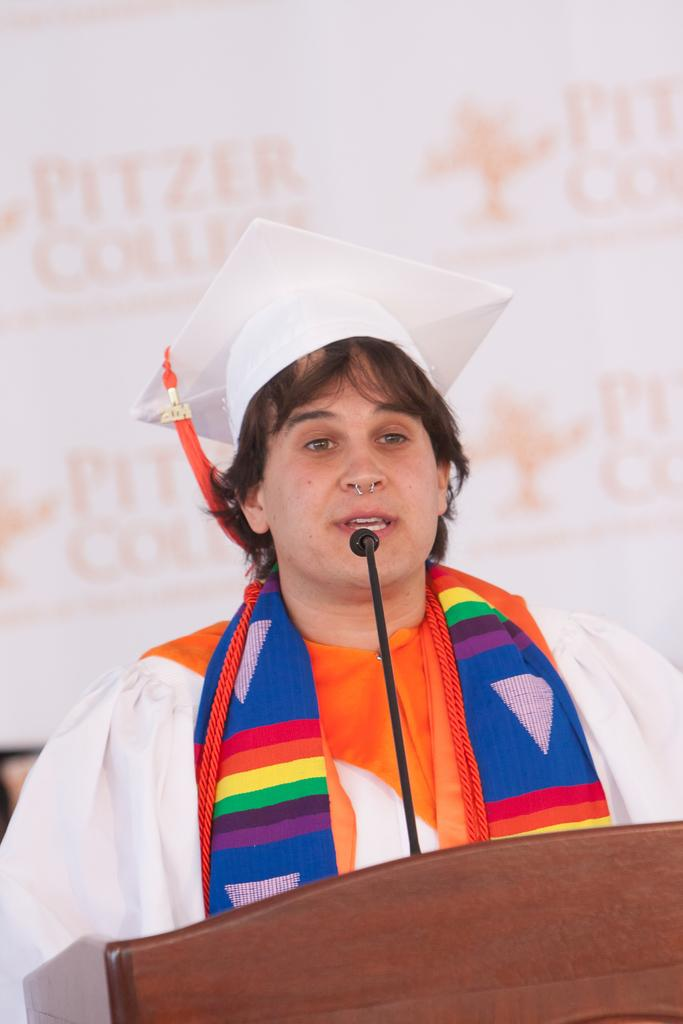What is the person in the image doing? The person appears to be standing near a podium and speaking into a microphone. Where is the microphone located in the image? The microphone is in front of the person, who is speaking into it. What can be seen in the background of the image? There is a poster visible in the background of the image. What type of shoes can be seen on the person's feet in the image? There is no information about the person's shoes in the image, as the focus is on the person standing near the podium and speaking into the microphone. 